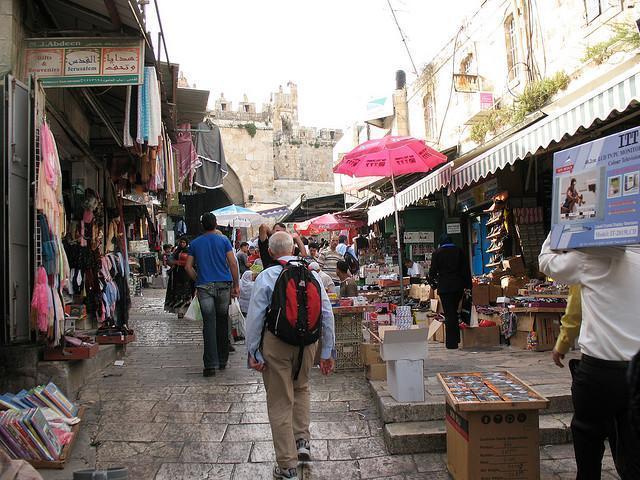How many steps are there on the right?
Give a very brief answer. 2. How many umbrellas are visible?
Give a very brief answer. 1. How many backpacks can be seen?
Give a very brief answer. 1. How many people are in the picture?
Give a very brief answer. 4. How many bananas is she holding?
Give a very brief answer. 0. 